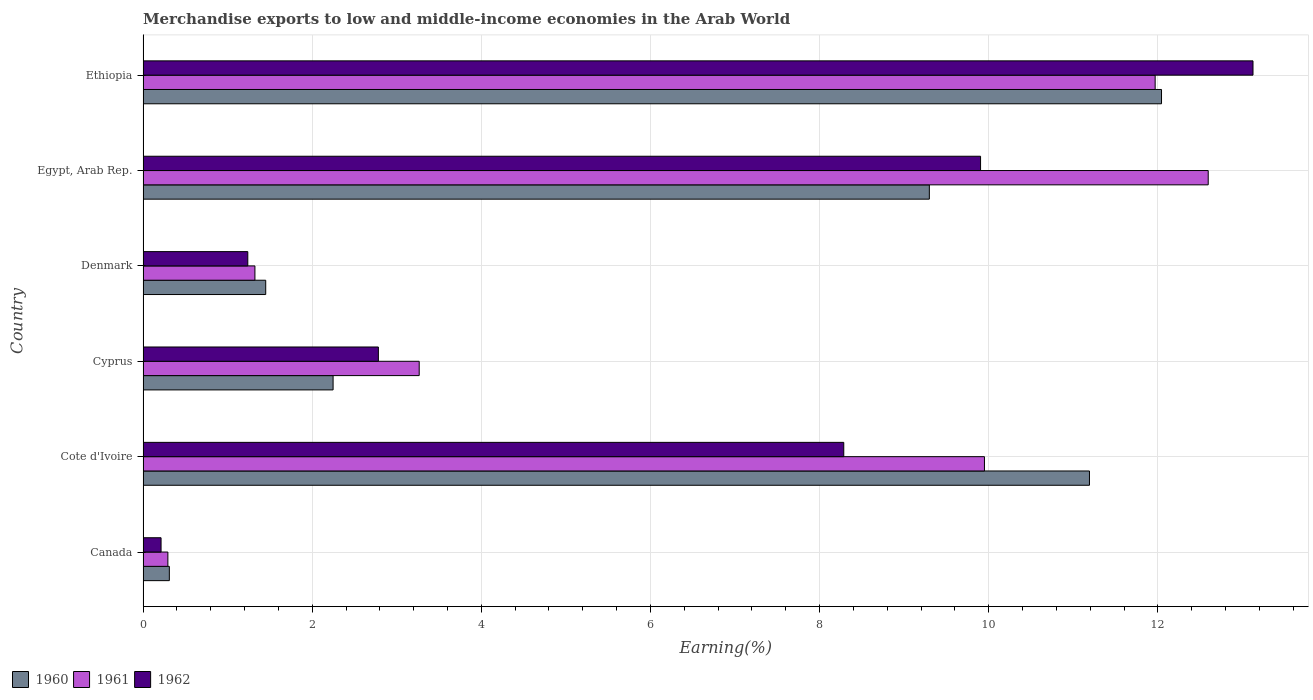How many groups of bars are there?
Your answer should be compact. 6. How many bars are there on the 1st tick from the top?
Provide a short and direct response. 3. How many bars are there on the 2nd tick from the bottom?
Make the answer very short. 3. What is the label of the 3rd group of bars from the top?
Offer a terse response. Denmark. In how many cases, is the number of bars for a given country not equal to the number of legend labels?
Your answer should be compact. 0. What is the percentage of amount earned from merchandise exports in 1960 in Ethiopia?
Make the answer very short. 12.04. Across all countries, what is the maximum percentage of amount earned from merchandise exports in 1960?
Provide a succinct answer. 12.04. Across all countries, what is the minimum percentage of amount earned from merchandise exports in 1962?
Provide a short and direct response. 0.21. In which country was the percentage of amount earned from merchandise exports in 1960 maximum?
Offer a very short reply. Ethiopia. In which country was the percentage of amount earned from merchandise exports in 1960 minimum?
Ensure brevity in your answer.  Canada. What is the total percentage of amount earned from merchandise exports in 1962 in the graph?
Your answer should be very brief. 35.55. What is the difference between the percentage of amount earned from merchandise exports in 1961 in Canada and that in Ethiopia?
Offer a very short reply. -11.67. What is the difference between the percentage of amount earned from merchandise exports in 1960 in Canada and the percentage of amount earned from merchandise exports in 1962 in Egypt, Arab Rep.?
Your answer should be compact. -9.59. What is the average percentage of amount earned from merchandise exports in 1961 per country?
Your answer should be very brief. 6.57. What is the difference between the percentage of amount earned from merchandise exports in 1961 and percentage of amount earned from merchandise exports in 1960 in Egypt, Arab Rep.?
Your answer should be compact. 3.3. What is the ratio of the percentage of amount earned from merchandise exports in 1962 in Canada to that in Ethiopia?
Provide a short and direct response. 0.02. Is the percentage of amount earned from merchandise exports in 1961 in Cote d'Ivoire less than that in Denmark?
Your answer should be very brief. No. What is the difference between the highest and the second highest percentage of amount earned from merchandise exports in 1961?
Ensure brevity in your answer.  0.63. What is the difference between the highest and the lowest percentage of amount earned from merchandise exports in 1961?
Give a very brief answer. 12.3. What does the 2nd bar from the top in Cyprus represents?
Make the answer very short. 1961. What does the 1st bar from the bottom in Egypt, Arab Rep. represents?
Offer a very short reply. 1960. Is it the case that in every country, the sum of the percentage of amount earned from merchandise exports in 1962 and percentage of amount earned from merchandise exports in 1961 is greater than the percentage of amount earned from merchandise exports in 1960?
Offer a very short reply. Yes. Are all the bars in the graph horizontal?
Offer a terse response. Yes. How many countries are there in the graph?
Your response must be concise. 6. What is the difference between two consecutive major ticks on the X-axis?
Offer a terse response. 2. Are the values on the major ticks of X-axis written in scientific E-notation?
Your answer should be compact. No. Where does the legend appear in the graph?
Your answer should be very brief. Bottom left. What is the title of the graph?
Give a very brief answer. Merchandise exports to low and middle-income economies in the Arab World. What is the label or title of the X-axis?
Give a very brief answer. Earning(%). What is the label or title of the Y-axis?
Your answer should be compact. Country. What is the Earning(%) in 1960 in Canada?
Ensure brevity in your answer.  0.31. What is the Earning(%) of 1961 in Canada?
Your answer should be very brief. 0.29. What is the Earning(%) of 1962 in Canada?
Provide a succinct answer. 0.21. What is the Earning(%) in 1960 in Cote d'Ivoire?
Your response must be concise. 11.19. What is the Earning(%) of 1961 in Cote d'Ivoire?
Make the answer very short. 9.95. What is the Earning(%) in 1962 in Cote d'Ivoire?
Give a very brief answer. 8.29. What is the Earning(%) in 1960 in Cyprus?
Provide a succinct answer. 2.25. What is the Earning(%) of 1961 in Cyprus?
Offer a terse response. 3.27. What is the Earning(%) in 1962 in Cyprus?
Offer a terse response. 2.78. What is the Earning(%) of 1960 in Denmark?
Provide a short and direct response. 1.45. What is the Earning(%) in 1961 in Denmark?
Give a very brief answer. 1.32. What is the Earning(%) in 1962 in Denmark?
Your answer should be very brief. 1.24. What is the Earning(%) of 1960 in Egypt, Arab Rep.?
Give a very brief answer. 9.3. What is the Earning(%) of 1961 in Egypt, Arab Rep.?
Offer a terse response. 12.6. What is the Earning(%) of 1962 in Egypt, Arab Rep.?
Ensure brevity in your answer.  9.9. What is the Earning(%) of 1960 in Ethiopia?
Your answer should be very brief. 12.04. What is the Earning(%) in 1961 in Ethiopia?
Make the answer very short. 11.97. What is the Earning(%) in 1962 in Ethiopia?
Provide a succinct answer. 13.12. Across all countries, what is the maximum Earning(%) in 1960?
Give a very brief answer. 12.04. Across all countries, what is the maximum Earning(%) in 1961?
Provide a succinct answer. 12.6. Across all countries, what is the maximum Earning(%) in 1962?
Provide a short and direct response. 13.12. Across all countries, what is the minimum Earning(%) of 1960?
Make the answer very short. 0.31. Across all countries, what is the minimum Earning(%) in 1961?
Provide a succinct answer. 0.29. Across all countries, what is the minimum Earning(%) in 1962?
Your answer should be compact. 0.21. What is the total Earning(%) in 1960 in the graph?
Provide a succinct answer. 36.54. What is the total Earning(%) in 1961 in the graph?
Offer a very short reply. 39.39. What is the total Earning(%) in 1962 in the graph?
Give a very brief answer. 35.55. What is the difference between the Earning(%) in 1960 in Canada and that in Cote d'Ivoire?
Your answer should be very brief. -10.88. What is the difference between the Earning(%) of 1961 in Canada and that in Cote d'Ivoire?
Provide a short and direct response. -9.66. What is the difference between the Earning(%) of 1962 in Canada and that in Cote d'Ivoire?
Provide a succinct answer. -8.07. What is the difference between the Earning(%) in 1960 in Canada and that in Cyprus?
Ensure brevity in your answer.  -1.94. What is the difference between the Earning(%) of 1961 in Canada and that in Cyprus?
Offer a very short reply. -2.97. What is the difference between the Earning(%) of 1962 in Canada and that in Cyprus?
Offer a terse response. -2.57. What is the difference between the Earning(%) in 1960 in Canada and that in Denmark?
Give a very brief answer. -1.14. What is the difference between the Earning(%) of 1961 in Canada and that in Denmark?
Provide a succinct answer. -1.03. What is the difference between the Earning(%) of 1962 in Canada and that in Denmark?
Keep it short and to the point. -1.03. What is the difference between the Earning(%) of 1960 in Canada and that in Egypt, Arab Rep.?
Offer a terse response. -8.99. What is the difference between the Earning(%) in 1961 in Canada and that in Egypt, Arab Rep.?
Make the answer very short. -12.3. What is the difference between the Earning(%) in 1962 in Canada and that in Egypt, Arab Rep.?
Your answer should be very brief. -9.69. What is the difference between the Earning(%) of 1960 in Canada and that in Ethiopia?
Your response must be concise. -11.73. What is the difference between the Earning(%) of 1961 in Canada and that in Ethiopia?
Give a very brief answer. -11.67. What is the difference between the Earning(%) in 1962 in Canada and that in Ethiopia?
Offer a terse response. -12.91. What is the difference between the Earning(%) in 1960 in Cote d'Ivoire and that in Cyprus?
Give a very brief answer. 8.94. What is the difference between the Earning(%) in 1961 in Cote d'Ivoire and that in Cyprus?
Provide a short and direct response. 6.68. What is the difference between the Earning(%) of 1962 in Cote d'Ivoire and that in Cyprus?
Provide a short and direct response. 5.5. What is the difference between the Earning(%) of 1960 in Cote d'Ivoire and that in Denmark?
Your answer should be very brief. 9.74. What is the difference between the Earning(%) of 1961 in Cote d'Ivoire and that in Denmark?
Provide a short and direct response. 8.63. What is the difference between the Earning(%) in 1962 in Cote d'Ivoire and that in Denmark?
Make the answer very short. 7.05. What is the difference between the Earning(%) of 1960 in Cote d'Ivoire and that in Egypt, Arab Rep.?
Your response must be concise. 1.89. What is the difference between the Earning(%) in 1961 in Cote d'Ivoire and that in Egypt, Arab Rep.?
Provide a short and direct response. -2.65. What is the difference between the Earning(%) in 1962 in Cote d'Ivoire and that in Egypt, Arab Rep.?
Provide a succinct answer. -1.62. What is the difference between the Earning(%) of 1960 in Cote d'Ivoire and that in Ethiopia?
Give a very brief answer. -0.85. What is the difference between the Earning(%) of 1961 in Cote d'Ivoire and that in Ethiopia?
Your answer should be very brief. -2.02. What is the difference between the Earning(%) of 1962 in Cote d'Ivoire and that in Ethiopia?
Your answer should be compact. -4.84. What is the difference between the Earning(%) of 1960 in Cyprus and that in Denmark?
Offer a very short reply. 0.8. What is the difference between the Earning(%) in 1961 in Cyprus and that in Denmark?
Your answer should be very brief. 1.94. What is the difference between the Earning(%) of 1962 in Cyprus and that in Denmark?
Give a very brief answer. 1.54. What is the difference between the Earning(%) of 1960 in Cyprus and that in Egypt, Arab Rep.?
Provide a short and direct response. -7.05. What is the difference between the Earning(%) in 1961 in Cyprus and that in Egypt, Arab Rep.?
Ensure brevity in your answer.  -9.33. What is the difference between the Earning(%) of 1962 in Cyprus and that in Egypt, Arab Rep.?
Offer a terse response. -7.12. What is the difference between the Earning(%) of 1960 in Cyprus and that in Ethiopia?
Give a very brief answer. -9.8. What is the difference between the Earning(%) of 1961 in Cyprus and that in Ethiopia?
Your answer should be very brief. -8.7. What is the difference between the Earning(%) in 1962 in Cyprus and that in Ethiopia?
Offer a very short reply. -10.34. What is the difference between the Earning(%) in 1960 in Denmark and that in Egypt, Arab Rep.?
Provide a succinct answer. -7.85. What is the difference between the Earning(%) in 1961 in Denmark and that in Egypt, Arab Rep.?
Provide a succinct answer. -11.27. What is the difference between the Earning(%) in 1962 in Denmark and that in Egypt, Arab Rep.?
Provide a short and direct response. -8.66. What is the difference between the Earning(%) of 1960 in Denmark and that in Ethiopia?
Your answer should be compact. -10.59. What is the difference between the Earning(%) of 1961 in Denmark and that in Ethiopia?
Offer a terse response. -10.65. What is the difference between the Earning(%) in 1962 in Denmark and that in Ethiopia?
Keep it short and to the point. -11.89. What is the difference between the Earning(%) of 1960 in Egypt, Arab Rep. and that in Ethiopia?
Your answer should be very brief. -2.75. What is the difference between the Earning(%) in 1961 in Egypt, Arab Rep. and that in Ethiopia?
Give a very brief answer. 0.63. What is the difference between the Earning(%) in 1962 in Egypt, Arab Rep. and that in Ethiopia?
Your response must be concise. -3.22. What is the difference between the Earning(%) in 1960 in Canada and the Earning(%) in 1961 in Cote d'Ivoire?
Provide a succinct answer. -9.64. What is the difference between the Earning(%) in 1960 in Canada and the Earning(%) in 1962 in Cote d'Ivoire?
Your answer should be compact. -7.98. What is the difference between the Earning(%) in 1961 in Canada and the Earning(%) in 1962 in Cote d'Ivoire?
Provide a succinct answer. -7.99. What is the difference between the Earning(%) in 1960 in Canada and the Earning(%) in 1961 in Cyprus?
Provide a succinct answer. -2.95. What is the difference between the Earning(%) of 1960 in Canada and the Earning(%) of 1962 in Cyprus?
Provide a succinct answer. -2.47. What is the difference between the Earning(%) of 1961 in Canada and the Earning(%) of 1962 in Cyprus?
Make the answer very short. -2.49. What is the difference between the Earning(%) in 1960 in Canada and the Earning(%) in 1961 in Denmark?
Offer a terse response. -1.01. What is the difference between the Earning(%) of 1960 in Canada and the Earning(%) of 1962 in Denmark?
Ensure brevity in your answer.  -0.93. What is the difference between the Earning(%) in 1961 in Canada and the Earning(%) in 1962 in Denmark?
Make the answer very short. -0.95. What is the difference between the Earning(%) in 1960 in Canada and the Earning(%) in 1961 in Egypt, Arab Rep.?
Provide a short and direct response. -12.28. What is the difference between the Earning(%) in 1960 in Canada and the Earning(%) in 1962 in Egypt, Arab Rep.?
Keep it short and to the point. -9.59. What is the difference between the Earning(%) of 1961 in Canada and the Earning(%) of 1962 in Egypt, Arab Rep.?
Make the answer very short. -9.61. What is the difference between the Earning(%) in 1960 in Canada and the Earning(%) in 1961 in Ethiopia?
Keep it short and to the point. -11.66. What is the difference between the Earning(%) in 1960 in Canada and the Earning(%) in 1962 in Ethiopia?
Provide a short and direct response. -12.81. What is the difference between the Earning(%) in 1961 in Canada and the Earning(%) in 1962 in Ethiopia?
Provide a short and direct response. -12.83. What is the difference between the Earning(%) of 1960 in Cote d'Ivoire and the Earning(%) of 1961 in Cyprus?
Offer a terse response. 7.93. What is the difference between the Earning(%) of 1960 in Cote d'Ivoire and the Earning(%) of 1962 in Cyprus?
Make the answer very short. 8.41. What is the difference between the Earning(%) in 1961 in Cote d'Ivoire and the Earning(%) in 1962 in Cyprus?
Provide a succinct answer. 7.17. What is the difference between the Earning(%) of 1960 in Cote d'Ivoire and the Earning(%) of 1961 in Denmark?
Keep it short and to the point. 9.87. What is the difference between the Earning(%) in 1960 in Cote d'Ivoire and the Earning(%) in 1962 in Denmark?
Provide a short and direct response. 9.95. What is the difference between the Earning(%) of 1961 in Cote d'Ivoire and the Earning(%) of 1962 in Denmark?
Your answer should be compact. 8.71. What is the difference between the Earning(%) of 1960 in Cote d'Ivoire and the Earning(%) of 1961 in Egypt, Arab Rep.?
Give a very brief answer. -1.4. What is the difference between the Earning(%) in 1960 in Cote d'Ivoire and the Earning(%) in 1962 in Egypt, Arab Rep.?
Offer a very short reply. 1.29. What is the difference between the Earning(%) in 1961 in Cote d'Ivoire and the Earning(%) in 1962 in Egypt, Arab Rep.?
Your answer should be very brief. 0.05. What is the difference between the Earning(%) of 1960 in Cote d'Ivoire and the Earning(%) of 1961 in Ethiopia?
Offer a very short reply. -0.78. What is the difference between the Earning(%) of 1960 in Cote d'Ivoire and the Earning(%) of 1962 in Ethiopia?
Make the answer very short. -1.93. What is the difference between the Earning(%) in 1961 in Cote d'Ivoire and the Earning(%) in 1962 in Ethiopia?
Your response must be concise. -3.18. What is the difference between the Earning(%) of 1960 in Cyprus and the Earning(%) of 1961 in Denmark?
Keep it short and to the point. 0.92. What is the difference between the Earning(%) in 1960 in Cyprus and the Earning(%) in 1962 in Denmark?
Ensure brevity in your answer.  1.01. What is the difference between the Earning(%) in 1961 in Cyprus and the Earning(%) in 1962 in Denmark?
Make the answer very short. 2.03. What is the difference between the Earning(%) of 1960 in Cyprus and the Earning(%) of 1961 in Egypt, Arab Rep.?
Keep it short and to the point. -10.35. What is the difference between the Earning(%) in 1960 in Cyprus and the Earning(%) in 1962 in Egypt, Arab Rep.?
Make the answer very short. -7.66. What is the difference between the Earning(%) of 1961 in Cyprus and the Earning(%) of 1962 in Egypt, Arab Rep.?
Your answer should be very brief. -6.64. What is the difference between the Earning(%) of 1960 in Cyprus and the Earning(%) of 1961 in Ethiopia?
Offer a very short reply. -9.72. What is the difference between the Earning(%) of 1960 in Cyprus and the Earning(%) of 1962 in Ethiopia?
Ensure brevity in your answer.  -10.88. What is the difference between the Earning(%) of 1961 in Cyprus and the Earning(%) of 1962 in Ethiopia?
Ensure brevity in your answer.  -9.86. What is the difference between the Earning(%) in 1960 in Denmark and the Earning(%) in 1961 in Egypt, Arab Rep.?
Keep it short and to the point. -11.15. What is the difference between the Earning(%) in 1960 in Denmark and the Earning(%) in 1962 in Egypt, Arab Rep.?
Ensure brevity in your answer.  -8.45. What is the difference between the Earning(%) in 1961 in Denmark and the Earning(%) in 1962 in Egypt, Arab Rep.?
Provide a short and direct response. -8.58. What is the difference between the Earning(%) in 1960 in Denmark and the Earning(%) in 1961 in Ethiopia?
Offer a very short reply. -10.52. What is the difference between the Earning(%) in 1960 in Denmark and the Earning(%) in 1962 in Ethiopia?
Give a very brief answer. -11.67. What is the difference between the Earning(%) in 1961 in Denmark and the Earning(%) in 1962 in Ethiopia?
Make the answer very short. -11.8. What is the difference between the Earning(%) of 1960 in Egypt, Arab Rep. and the Earning(%) of 1961 in Ethiopia?
Your answer should be very brief. -2.67. What is the difference between the Earning(%) of 1960 in Egypt, Arab Rep. and the Earning(%) of 1962 in Ethiopia?
Offer a terse response. -3.83. What is the difference between the Earning(%) in 1961 in Egypt, Arab Rep. and the Earning(%) in 1962 in Ethiopia?
Your answer should be very brief. -0.53. What is the average Earning(%) of 1960 per country?
Your answer should be compact. 6.09. What is the average Earning(%) in 1961 per country?
Make the answer very short. 6.57. What is the average Earning(%) of 1962 per country?
Provide a succinct answer. 5.92. What is the difference between the Earning(%) of 1960 and Earning(%) of 1961 in Canada?
Your response must be concise. 0.02. What is the difference between the Earning(%) of 1960 and Earning(%) of 1962 in Canada?
Provide a succinct answer. 0.1. What is the difference between the Earning(%) of 1961 and Earning(%) of 1962 in Canada?
Your answer should be very brief. 0.08. What is the difference between the Earning(%) of 1960 and Earning(%) of 1961 in Cote d'Ivoire?
Make the answer very short. 1.24. What is the difference between the Earning(%) of 1960 and Earning(%) of 1962 in Cote d'Ivoire?
Offer a terse response. 2.91. What is the difference between the Earning(%) in 1961 and Earning(%) in 1962 in Cote d'Ivoire?
Your answer should be compact. 1.66. What is the difference between the Earning(%) in 1960 and Earning(%) in 1961 in Cyprus?
Provide a succinct answer. -1.02. What is the difference between the Earning(%) of 1960 and Earning(%) of 1962 in Cyprus?
Keep it short and to the point. -0.54. What is the difference between the Earning(%) in 1961 and Earning(%) in 1962 in Cyprus?
Provide a short and direct response. 0.48. What is the difference between the Earning(%) of 1960 and Earning(%) of 1961 in Denmark?
Make the answer very short. 0.13. What is the difference between the Earning(%) of 1960 and Earning(%) of 1962 in Denmark?
Your response must be concise. 0.21. What is the difference between the Earning(%) in 1961 and Earning(%) in 1962 in Denmark?
Your answer should be compact. 0.08. What is the difference between the Earning(%) of 1960 and Earning(%) of 1961 in Egypt, Arab Rep.?
Give a very brief answer. -3.3. What is the difference between the Earning(%) of 1960 and Earning(%) of 1962 in Egypt, Arab Rep.?
Offer a terse response. -0.61. What is the difference between the Earning(%) in 1961 and Earning(%) in 1962 in Egypt, Arab Rep.?
Your answer should be very brief. 2.69. What is the difference between the Earning(%) in 1960 and Earning(%) in 1961 in Ethiopia?
Keep it short and to the point. 0.08. What is the difference between the Earning(%) of 1960 and Earning(%) of 1962 in Ethiopia?
Give a very brief answer. -1.08. What is the difference between the Earning(%) of 1961 and Earning(%) of 1962 in Ethiopia?
Provide a succinct answer. -1.16. What is the ratio of the Earning(%) in 1960 in Canada to that in Cote d'Ivoire?
Offer a terse response. 0.03. What is the ratio of the Earning(%) in 1961 in Canada to that in Cote d'Ivoire?
Offer a very short reply. 0.03. What is the ratio of the Earning(%) of 1962 in Canada to that in Cote d'Ivoire?
Offer a very short reply. 0.03. What is the ratio of the Earning(%) in 1960 in Canada to that in Cyprus?
Your answer should be very brief. 0.14. What is the ratio of the Earning(%) of 1961 in Canada to that in Cyprus?
Provide a short and direct response. 0.09. What is the ratio of the Earning(%) in 1962 in Canada to that in Cyprus?
Give a very brief answer. 0.08. What is the ratio of the Earning(%) in 1960 in Canada to that in Denmark?
Provide a short and direct response. 0.21. What is the ratio of the Earning(%) in 1961 in Canada to that in Denmark?
Ensure brevity in your answer.  0.22. What is the ratio of the Earning(%) in 1962 in Canada to that in Denmark?
Offer a very short reply. 0.17. What is the ratio of the Earning(%) of 1960 in Canada to that in Egypt, Arab Rep.?
Your answer should be very brief. 0.03. What is the ratio of the Earning(%) of 1961 in Canada to that in Egypt, Arab Rep.?
Give a very brief answer. 0.02. What is the ratio of the Earning(%) of 1962 in Canada to that in Egypt, Arab Rep.?
Make the answer very short. 0.02. What is the ratio of the Earning(%) in 1960 in Canada to that in Ethiopia?
Ensure brevity in your answer.  0.03. What is the ratio of the Earning(%) in 1961 in Canada to that in Ethiopia?
Give a very brief answer. 0.02. What is the ratio of the Earning(%) in 1962 in Canada to that in Ethiopia?
Provide a succinct answer. 0.02. What is the ratio of the Earning(%) of 1960 in Cote d'Ivoire to that in Cyprus?
Make the answer very short. 4.98. What is the ratio of the Earning(%) in 1961 in Cote d'Ivoire to that in Cyprus?
Provide a succinct answer. 3.05. What is the ratio of the Earning(%) of 1962 in Cote d'Ivoire to that in Cyprus?
Offer a terse response. 2.98. What is the ratio of the Earning(%) in 1960 in Cote d'Ivoire to that in Denmark?
Your answer should be compact. 7.72. What is the ratio of the Earning(%) in 1961 in Cote d'Ivoire to that in Denmark?
Ensure brevity in your answer.  7.52. What is the ratio of the Earning(%) of 1962 in Cote d'Ivoire to that in Denmark?
Offer a very short reply. 6.69. What is the ratio of the Earning(%) of 1960 in Cote d'Ivoire to that in Egypt, Arab Rep.?
Your answer should be very brief. 1.2. What is the ratio of the Earning(%) of 1961 in Cote d'Ivoire to that in Egypt, Arab Rep.?
Give a very brief answer. 0.79. What is the ratio of the Earning(%) of 1962 in Cote d'Ivoire to that in Egypt, Arab Rep.?
Keep it short and to the point. 0.84. What is the ratio of the Earning(%) of 1960 in Cote d'Ivoire to that in Ethiopia?
Offer a terse response. 0.93. What is the ratio of the Earning(%) of 1961 in Cote d'Ivoire to that in Ethiopia?
Make the answer very short. 0.83. What is the ratio of the Earning(%) of 1962 in Cote d'Ivoire to that in Ethiopia?
Keep it short and to the point. 0.63. What is the ratio of the Earning(%) in 1960 in Cyprus to that in Denmark?
Offer a very short reply. 1.55. What is the ratio of the Earning(%) of 1961 in Cyprus to that in Denmark?
Provide a short and direct response. 2.47. What is the ratio of the Earning(%) of 1962 in Cyprus to that in Denmark?
Provide a succinct answer. 2.25. What is the ratio of the Earning(%) of 1960 in Cyprus to that in Egypt, Arab Rep.?
Give a very brief answer. 0.24. What is the ratio of the Earning(%) of 1961 in Cyprus to that in Egypt, Arab Rep.?
Your answer should be very brief. 0.26. What is the ratio of the Earning(%) of 1962 in Cyprus to that in Egypt, Arab Rep.?
Your answer should be compact. 0.28. What is the ratio of the Earning(%) of 1960 in Cyprus to that in Ethiopia?
Ensure brevity in your answer.  0.19. What is the ratio of the Earning(%) of 1961 in Cyprus to that in Ethiopia?
Give a very brief answer. 0.27. What is the ratio of the Earning(%) of 1962 in Cyprus to that in Ethiopia?
Your response must be concise. 0.21. What is the ratio of the Earning(%) in 1960 in Denmark to that in Egypt, Arab Rep.?
Keep it short and to the point. 0.16. What is the ratio of the Earning(%) in 1961 in Denmark to that in Egypt, Arab Rep.?
Give a very brief answer. 0.1. What is the ratio of the Earning(%) of 1962 in Denmark to that in Egypt, Arab Rep.?
Provide a short and direct response. 0.13. What is the ratio of the Earning(%) of 1960 in Denmark to that in Ethiopia?
Provide a succinct answer. 0.12. What is the ratio of the Earning(%) of 1961 in Denmark to that in Ethiopia?
Your answer should be compact. 0.11. What is the ratio of the Earning(%) in 1962 in Denmark to that in Ethiopia?
Your response must be concise. 0.09. What is the ratio of the Earning(%) in 1960 in Egypt, Arab Rep. to that in Ethiopia?
Your answer should be very brief. 0.77. What is the ratio of the Earning(%) in 1961 in Egypt, Arab Rep. to that in Ethiopia?
Give a very brief answer. 1.05. What is the ratio of the Earning(%) in 1962 in Egypt, Arab Rep. to that in Ethiopia?
Keep it short and to the point. 0.75. What is the difference between the highest and the second highest Earning(%) in 1960?
Give a very brief answer. 0.85. What is the difference between the highest and the second highest Earning(%) in 1961?
Give a very brief answer. 0.63. What is the difference between the highest and the second highest Earning(%) in 1962?
Offer a very short reply. 3.22. What is the difference between the highest and the lowest Earning(%) of 1960?
Give a very brief answer. 11.73. What is the difference between the highest and the lowest Earning(%) of 1961?
Provide a short and direct response. 12.3. What is the difference between the highest and the lowest Earning(%) of 1962?
Keep it short and to the point. 12.91. 